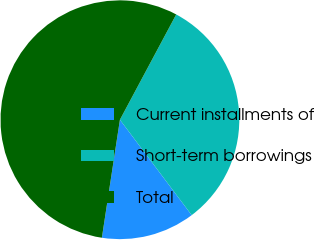Convert chart to OTSL. <chart><loc_0><loc_0><loc_500><loc_500><pie_chart><fcel>Current installments of<fcel>Short-term borrowings<fcel>Total<nl><fcel>12.68%<fcel>31.92%<fcel>55.4%<nl></chart> 